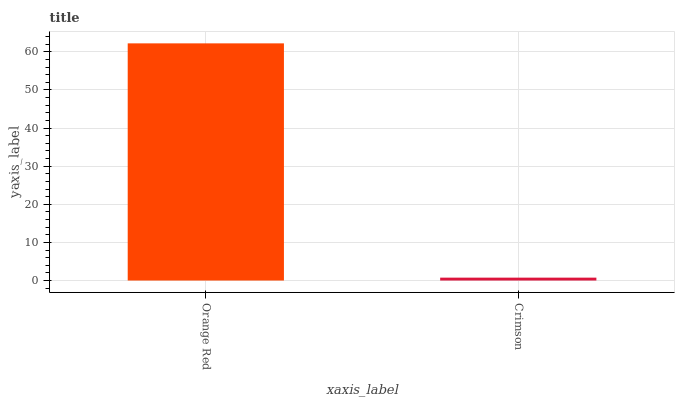Is Crimson the minimum?
Answer yes or no. Yes. Is Orange Red the maximum?
Answer yes or no. Yes. Is Crimson the maximum?
Answer yes or no. No. Is Orange Red greater than Crimson?
Answer yes or no. Yes. Is Crimson less than Orange Red?
Answer yes or no. Yes. Is Crimson greater than Orange Red?
Answer yes or no. No. Is Orange Red less than Crimson?
Answer yes or no. No. Is Orange Red the high median?
Answer yes or no. Yes. Is Crimson the low median?
Answer yes or no. Yes. Is Crimson the high median?
Answer yes or no. No. Is Orange Red the low median?
Answer yes or no. No. 